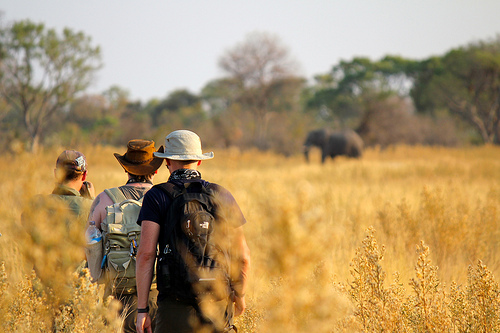Are there any elephants on the plain? Yes, there are elephants on the plain. 